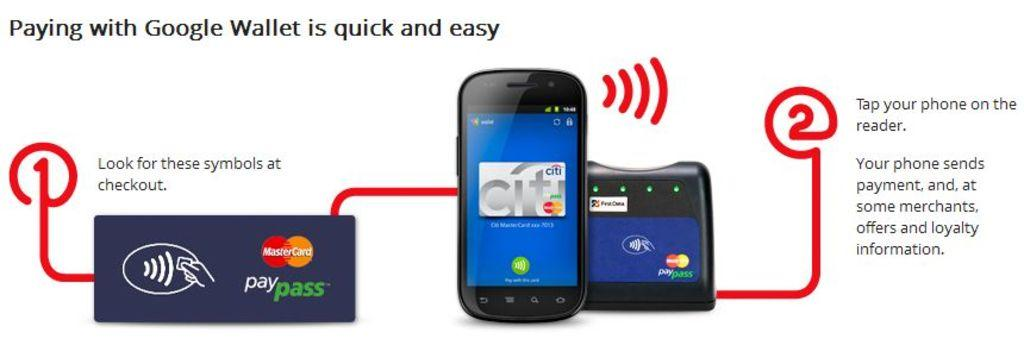<image>
Summarize the visual content of the image. Two cell phones, both with MasterCard symbols on the screen, are on an advertisement for Google wallet. 